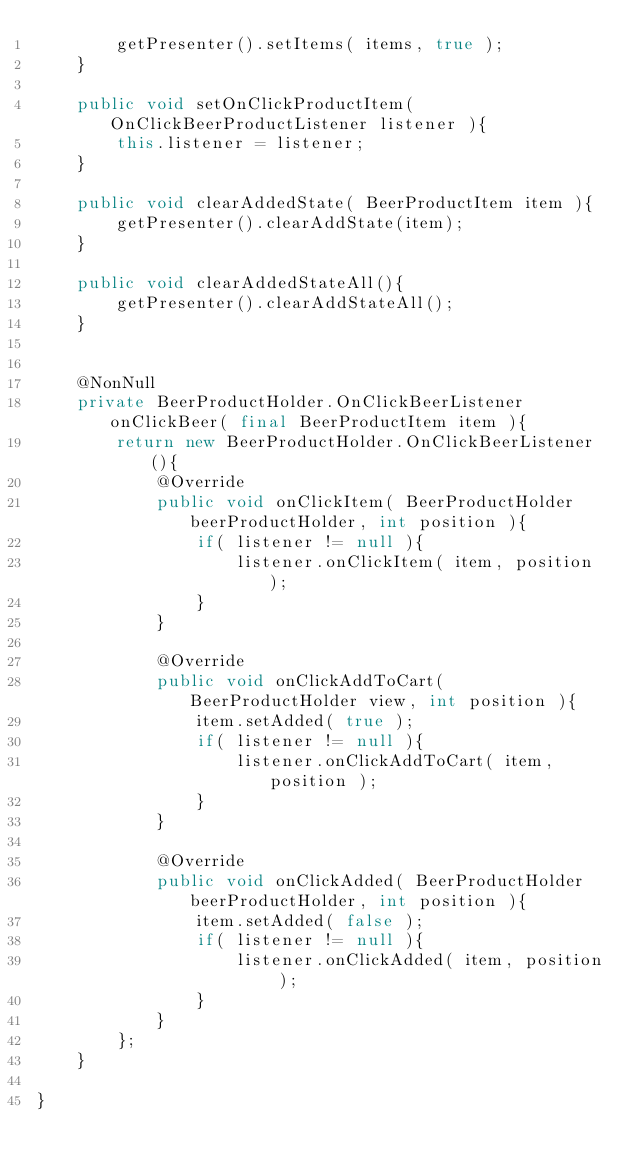Convert code to text. <code><loc_0><loc_0><loc_500><loc_500><_Java_>        getPresenter().setItems( items, true );
    }

    public void setOnClickProductItem( OnClickBeerProductListener listener ){
        this.listener = listener;
    }

    public void clearAddedState( BeerProductItem item ){
        getPresenter().clearAddState(item);
    }

    public void clearAddedStateAll(){
        getPresenter().clearAddStateAll();
    }


    @NonNull
    private BeerProductHolder.OnClickBeerListener onClickBeer( final BeerProductItem item ){
        return new BeerProductHolder.OnClickBeerListener(){
            @Override
            public void onClickItem( BeerProductHolder beerProductHolder, int position ){
                if( listener != null ){
                    listener.onClickItem( item, position );
                }
            }

            @Override
            public void onClickAddToCart( BeerProductHolder view, int position ){
                item.setAdded( true );
                if( listener != null ){
                    listener.onClickAddToCart( item, position );
                }
            }

            @Override
            public void onClickAdded( BeerProductHolder beerProductHolder, int position ){
                item.setAdded( false );
                if( listener != null ){
                    listener.onClickAdded( item, position );
                }
            }
        };
    }

}
</code> 